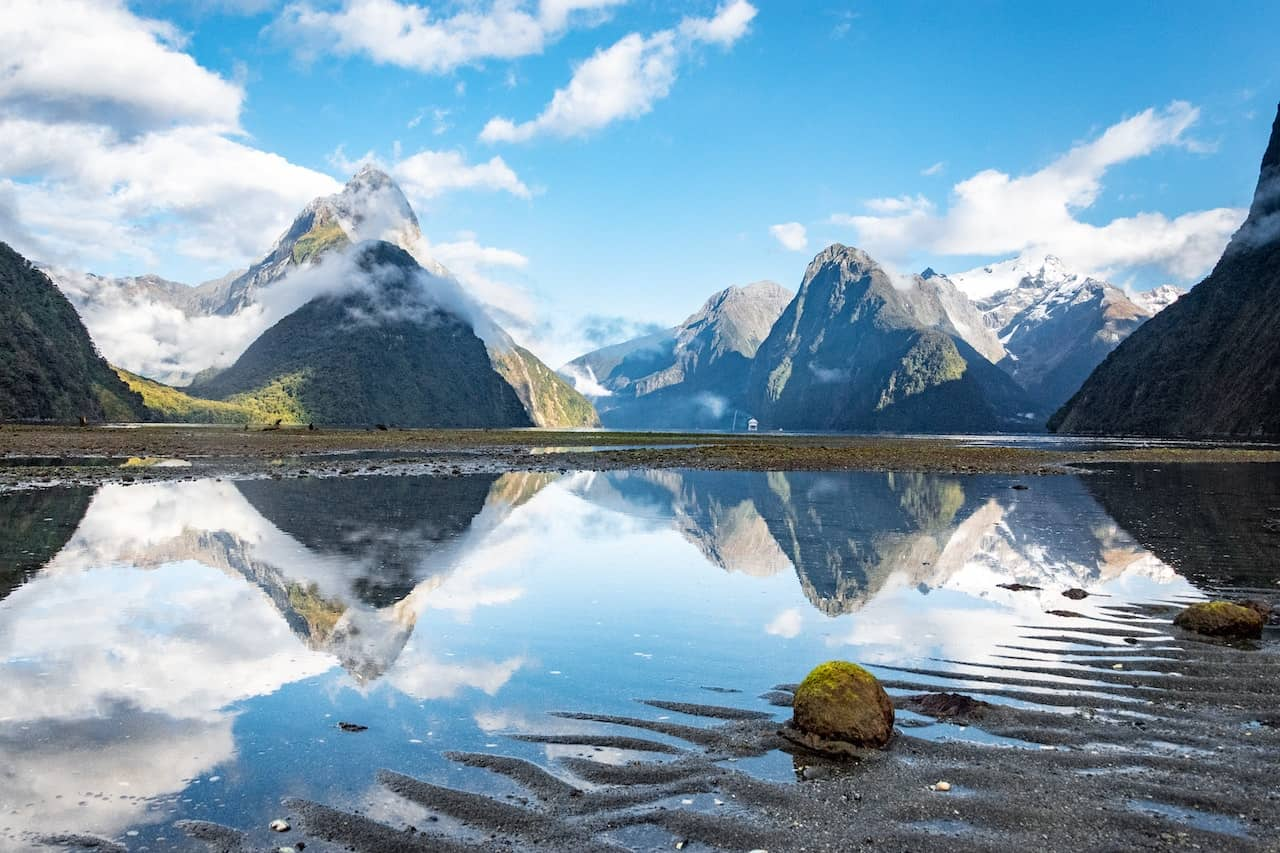What time of day does this photo seem to have been taken? This photo appears to have been taken in the morning, as indicated by the soft quality of the light and the minimal shadows. The gentle illumination enhances the serene and peaceful essence of the scene. 